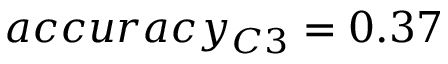<formula> <loc_0><loc_0><loc_500><loc_500>a c c u r a c y _ { C 3 } = 0 . 3 7</formula> 